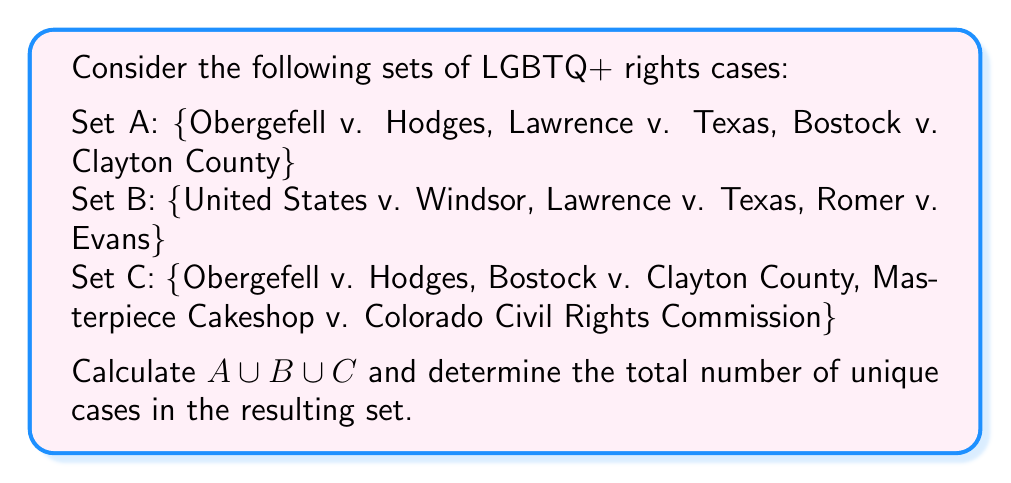Show me your answer to this math problem. To solve this problem, we need to find the union of sets A, B, and C, then count the number of unique elements in the resulting set.

Step 1: Identify all unique elements across the three sets.
- Obergefell v. Hodges (in A and C)
- Lawrence v. Texas (in A and B)
- Bostock v. Clayton County (in A and C)
- United States v. Windsor (in B)
- Romer v. Evans (in B)
- Masterpiece Cakeshop v. Colorado Civil Rights Commission (in C)

Step 2: Write out the union of the sets.
$A \cup B \cup C = \{$ Obergefell v. Hodges, Lawrence v. Texas, Bostock v. Clayton County, United States v. Windsor, Romer v. Evans, Masterpiece Cakeshop v. Colorado Civil Rights Commission $\}$

Step 3: Count the number of unique elements in the union.
There are 6 unique cases in the resulting set.

The union operation combines all elements from the sets without duplicating any cases that appear in multiple sets. This is particularly relevant for a law professor following LGBTQ+ rights cases, as it provides a comprehensive list of significant cases across different aspects of LGBTQ+ rights.
Answer: $A \cup B \cup C = \{$ Obergefell v. Hodges, Lawrence v. Texas, Bostock v. Clayton County, United States v. Windsor, Romer v. Evans, Masterpiece Cakeshop v. Colorado Civil Rights Commission $\}$

Number of unique cases: 6 